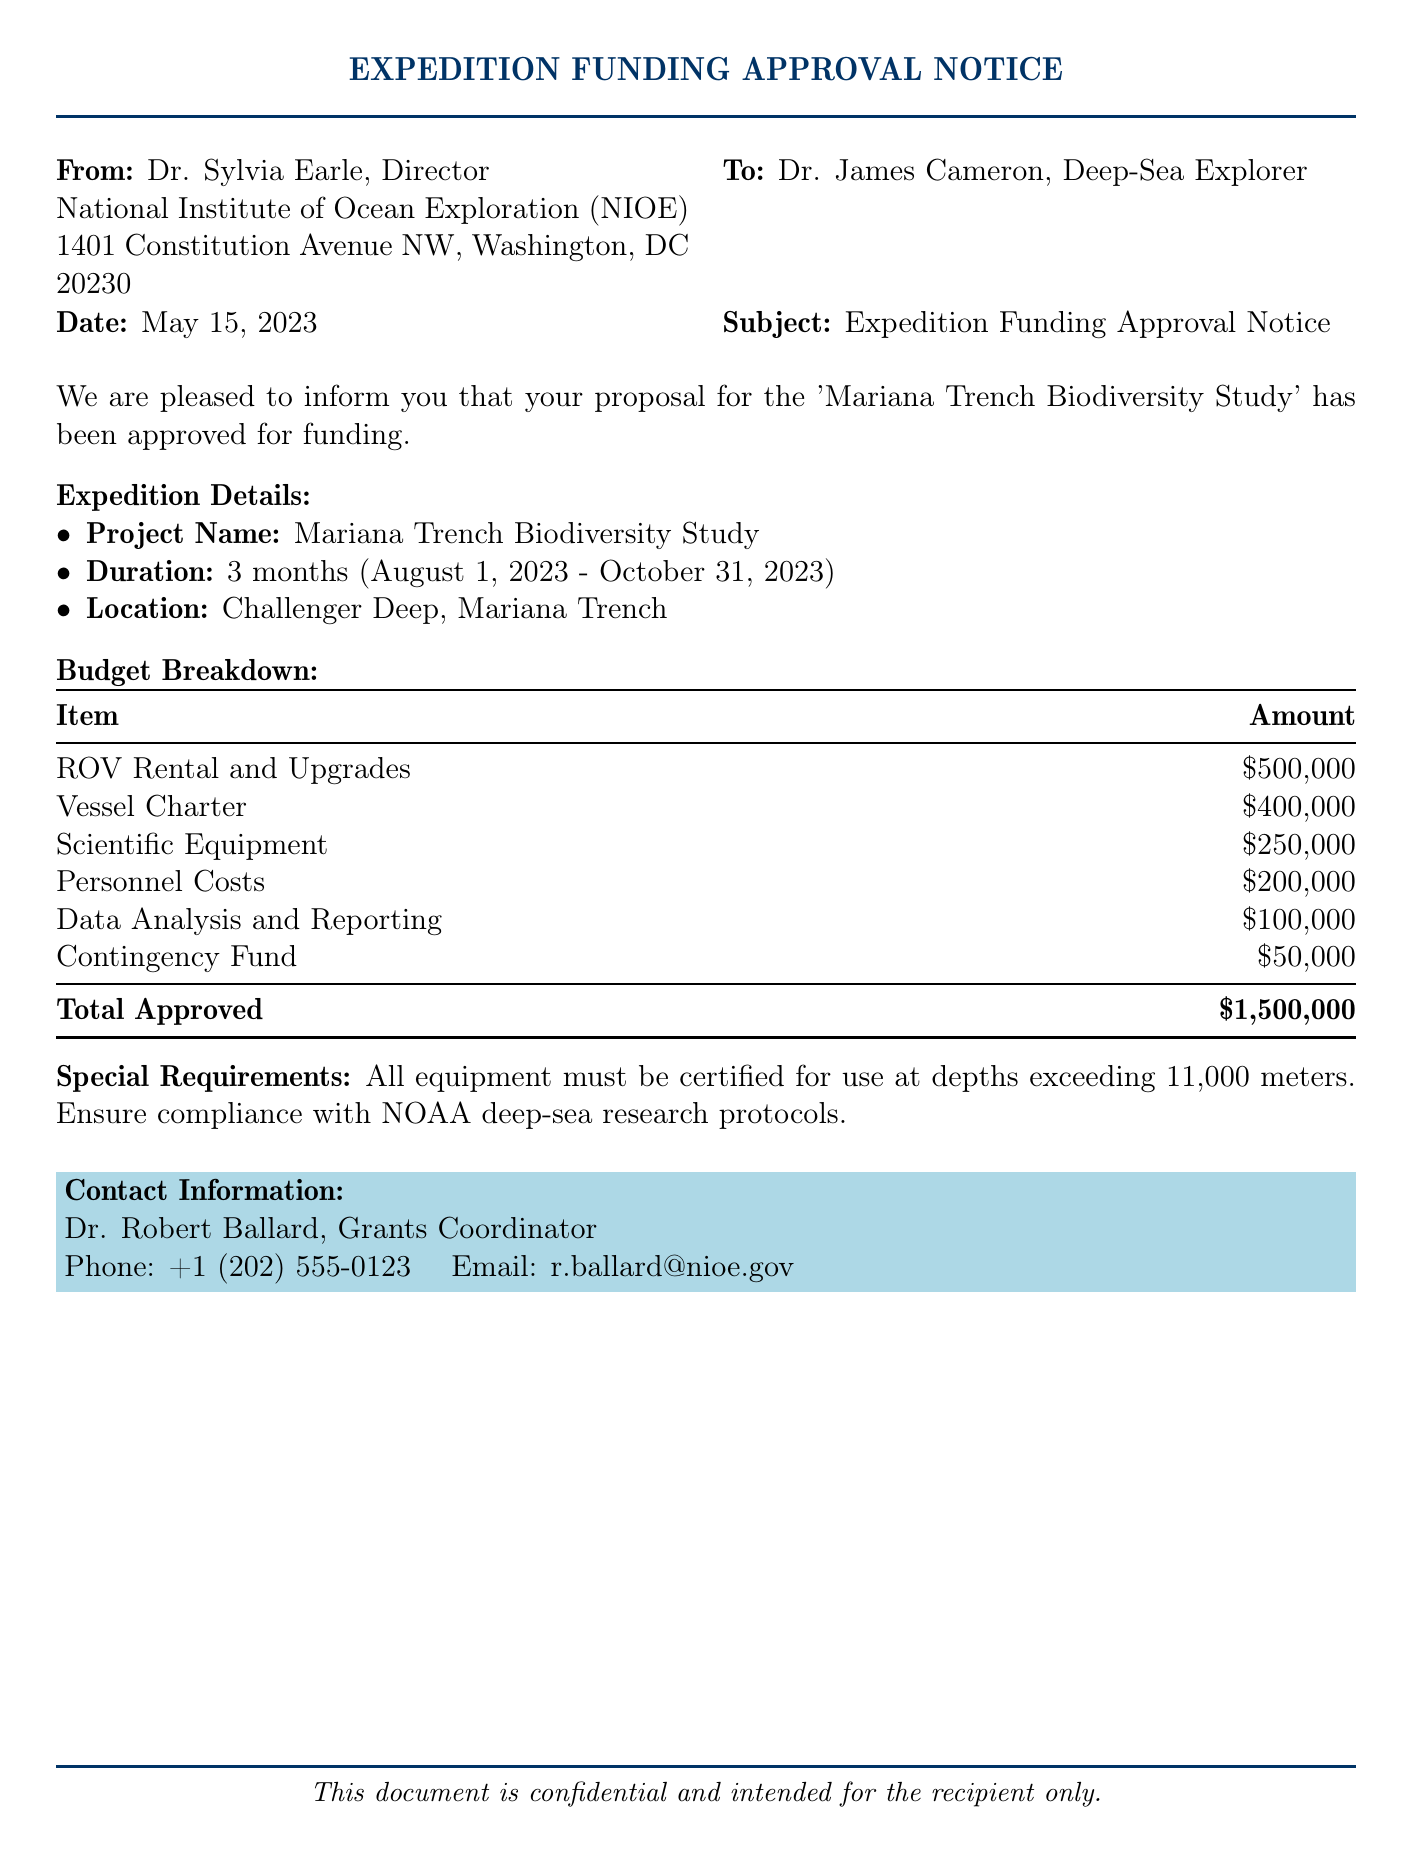what is the project name? The project name is explicitly mentioned in the document under the expedition details section.
Answer: Mariana Trench Biodiversity Study who is the recipient of the funding approval notice? The recipient of the notice is stated in the "To" section of the document.
Answer: Dr. James Cameron what is the total approved budget? The total approved budget is summarized in the budget breakdown table at the bottom of the document.
Answer: $1,500,000 how long is the expedition duration? The expedition duration is described in the expedition details section, specifying the start and end dates.
Answer: 3 months what is the amount allocated for scientific equipment? The amount allocated for scientific equipment is found in the budget breakdown table.
Answer: $250,000 who is the grants coordinator? The grants coordinator's name is provided in the contact information section of the document.
Answer: Dr. Robert Ballard what are the special requirements mentioned? The special requirements are outlined specifically in their own section, asking for compliance with certain protocols.
Answer: All equipment must be certified for use at depths exceeding 11,000 meters when was the funding approval notice issued? The date of the notice is clearly stated in the document.
Answer: May 15, 2023 what is the amount allocated for vessel charter? The amount for vessel charter is detailed in the budget breakdown table.
Answer: $400,000 